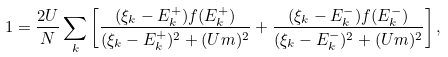<formula> <loc_0><loc_0><loc_500><loc_500>1 = \frac { 2 U } { N } \sum _ { k } \left [ \frac { ( \xi _ { k } - E ^ { + } _ { k } ) f ( E ^ { + } _ { k } ) } { ( \xi _ { k } - E ^ { + } _ { k } ) ^ { 2 } + ( U m ) ^ { 2 } } + \frac { ( \xi _ { k } - E ^ { - } _ { k } ) f ( E ^ { - } _ { k } ) } { ( \xi _ { k } - E ^ { - } _ { k } ) ^ { 2 } + ( U m ) ^ { 2 } } \right ] ,</formula> 